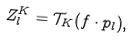Convert formula to latex. <formula><loc_0><loc_0><loc_500><loc_500>Z _ { l } ^ { K } = \mathcal { T } _ { K } ( f \cdot p _ { l } ) ,</formula> 